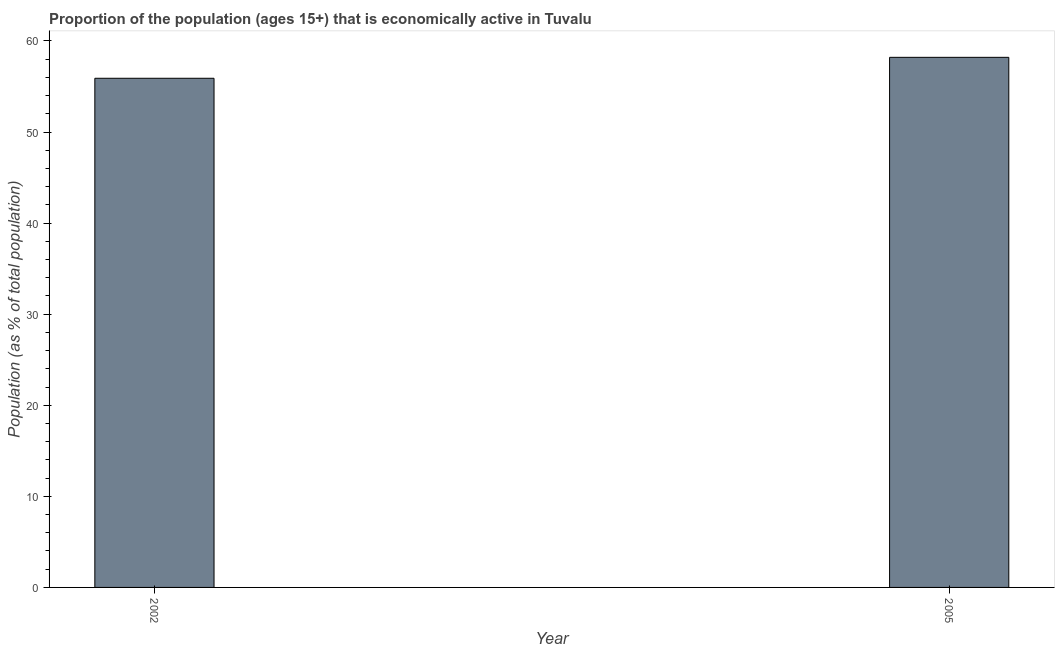Does the graph contain any zero values?
Make the answer very short. No. What is the title of the graph?
Give a very brief answer. Proportion of the population (ages 15+) that is economically active in Tuvalu. What is the label or title of the X-axis?
Offer a very short reply. Year. What is the label or title of the Y-axis?
Make the answer very short. Population (as % of total population). What is the percentage of economically active population in 2002?
Provide a short and direct response. 55.9. Across all years, what is the maximum percentage of economically active population?
Provide a short and direct response. 58.2. Across all years, what is the minimum percentage of economically active population?
Make the answer very short. 55.9. In which year was the percentage of economically active population minimum?
Give a very brief answer. 2002. What is the sum of the percentage of economically active population?
Your response must be concise. 114.1. What is the difference between the percentage of economically active population in 2002 and 2005?
Give a very brief answer. -2.3. What is the average percentage of economically active population per year?
Give a very brief answer. 57.05. What is the median percentage of economically active population?
Make the answer very short. 57.05. Do a majority of the years between 2002 and 2005 (inclusive) have percentage of economically active population greater than 52 %?
Offer a terse response. Yes. What is the ratio of the percentage of economically active population in 2002 to that in 2005?
Your answer should be compact. 0.96. In how many years, is the percentage of economically active population greater than the average percentage of economically active population taken over all years?
Your answer should be very brief. 1. How many years are there in the graph?
Keep it short and to the point. 2. What is the difference between two consecutive major ticks on the Y-axis?
Provide a succinct answer. 10. Are the values on the major ticks of Y-axis written in scientific E-notation?
Offer a terse response. No. What is the Population (as % of total population) of 2002?
Your answer should be compact. 55.9. What is the Population (as % of total population) of 2005?
Keep it short and to the point. 58.2. What is the difference between the Population (as % of total population) in 2002 and 2005?
Provide a succinct answer. -2.3. 